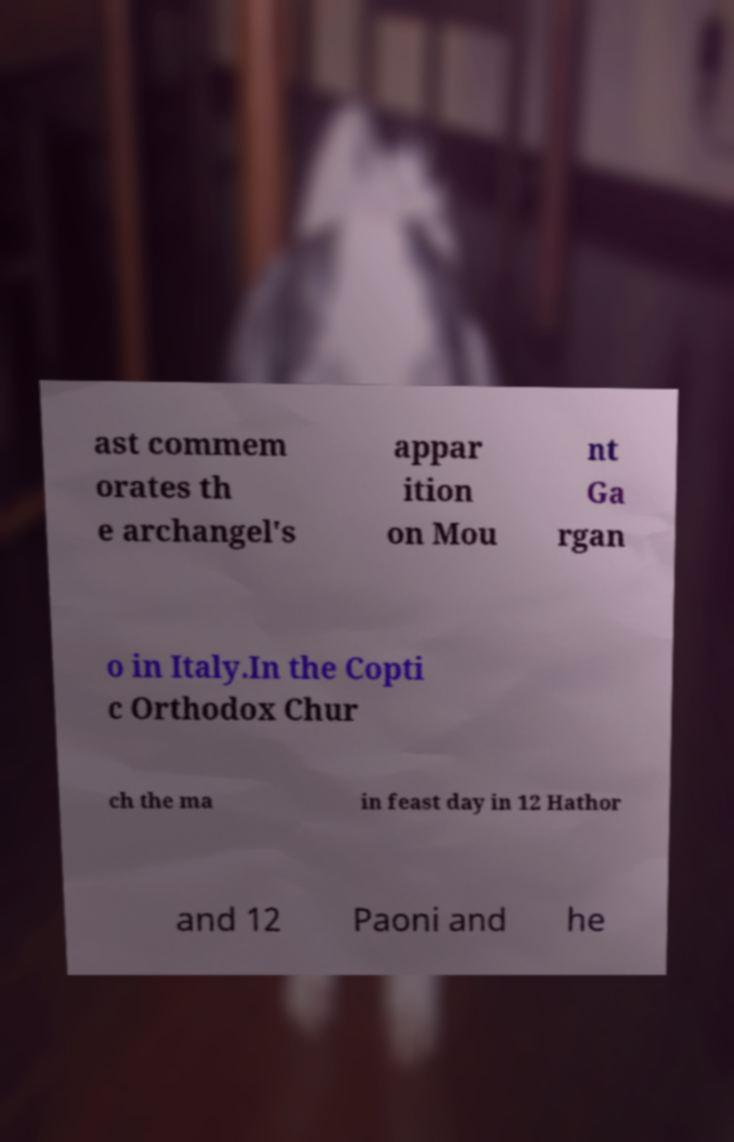I need the written content from this picture converted into text. Can you do that? ast commem orates th e archangel's appar ition on Mou nt Ga rgan o in Italy.In the Copti c Orthodox Chur ch the ma in feast day in 12 Hathor and 12 Paoni and he 